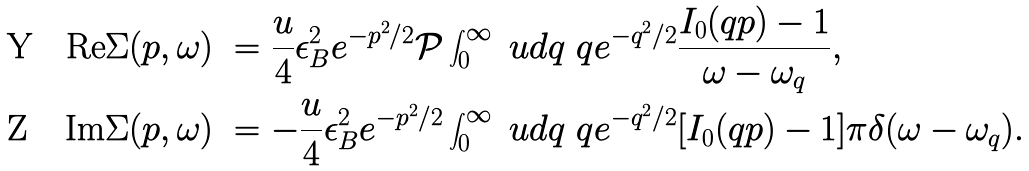<formula> <loc_0><loc_0><loc_500><loc_500>\text {Re} \Sigma ( p , \omega ) \ & = \frac { u } { 4 } \epsilon _ { B } ^ { 2 } e ^ { - p ^ { 2 } / 2 } \mathcal { P } \int ^ { \infty } _ { 0 } \ u d q \ q e ^ { - q ^ { 2 } / 2 } \frac { I _ { 0 } ( q p ) - 1 } { \omega - \omega _ { q } } , \\ \text {Im} \Sigma ( p , \omega ) \ & = - \frac { u } { 4 } \epsilon _ { B } ^ { 2 } e ^ { - p ^ { 2 } / 2 } \int ^ { \infty } _ { 0 } \ u d q \ q e ^ { - q ^ { 2 } / 2 } [ I _ { 0 } ( q p ) - 1 ] \pi \delta ( \omega - \omega _ { q } ) .</formula> 